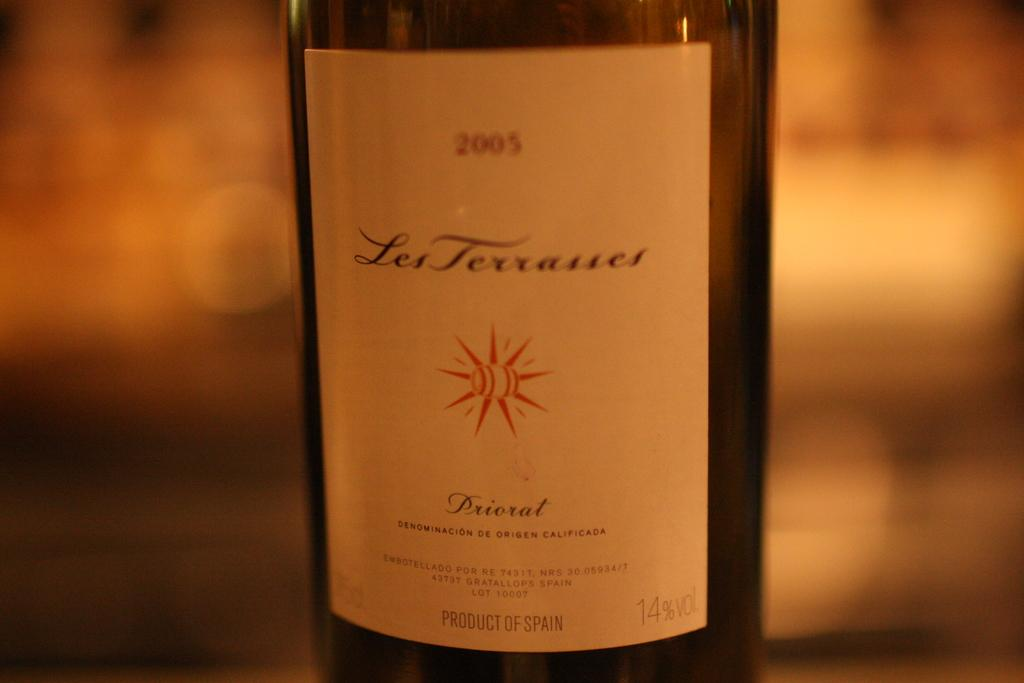<image>
Write a terse but informative summary of the picture. A 2005 bottle of Les Terrasses Priorat wine is shown. 